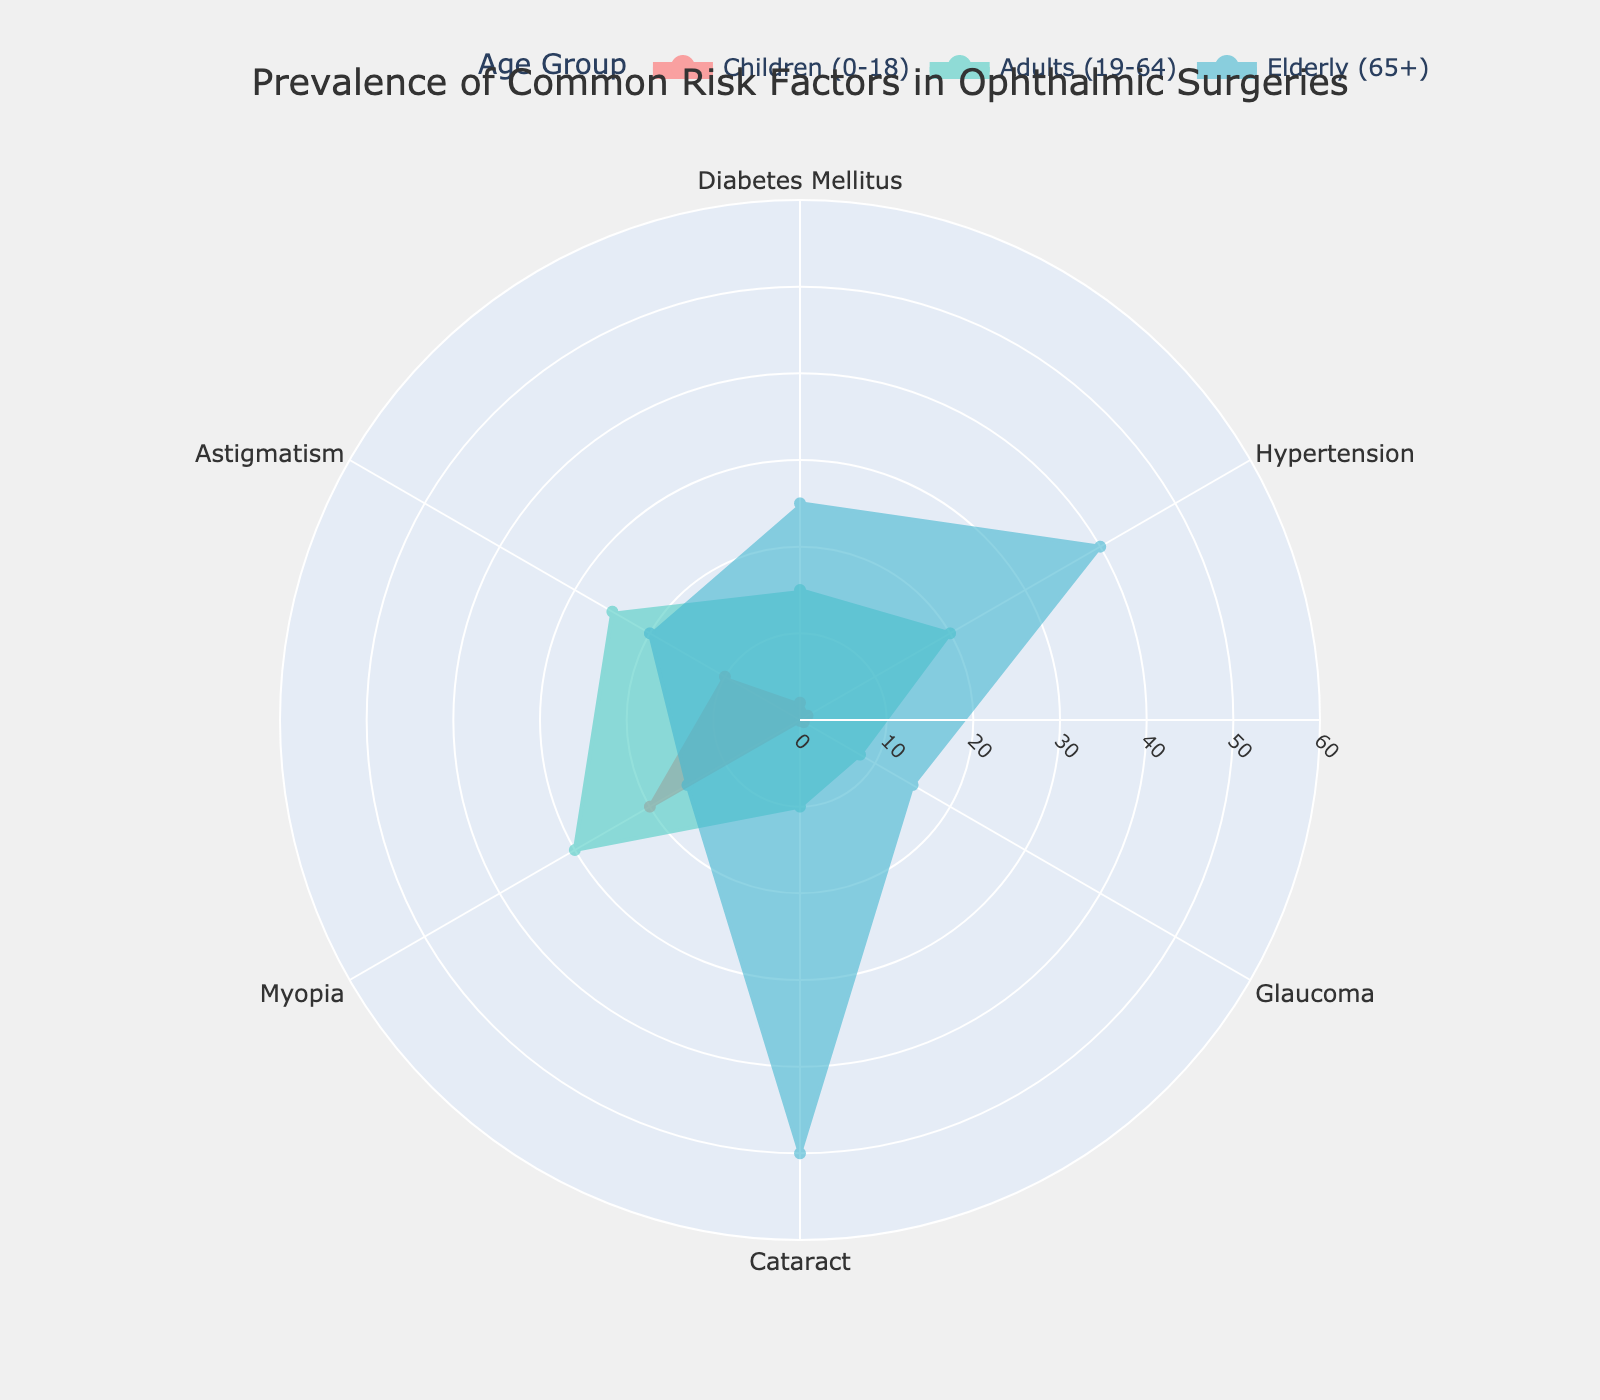What is the title of the figure? The title is usually located at the top of the figure and is straightforward to read. In this case, it states, "Prevalence of Common Risk Factors in Ophthalmic Surgeries."
Answer: Prevalence of Common Risk Factors in Ophthalmic Surgeries Which age group has the highest percentage of Hypertension? By inspecting the filled areas and reading the data labels around the polar chart, we can see that the age group "Elderly (65+)" has the largest radial distance in the Hypertension sector.
Answer: Elderly (65+) What is the difference in the prevalence of Myopia between Children and Adults? By reading the percentages from the labels or from the radial distances in the Myopia sector, we see Children (0-18) have 20% and Adults (19-64) have 30%. The difference is calculated as 30% - 20%.
Answer: 10% Which risk factor shows the largest increase in percentage from Children to Elderly? To determine this, we examine each risk factor's percentage for Children and Elderly. The risk factor with the largest difference (subtraction) indicates the largest increase. Cataract has the largest increase from 0.1% in Children to 50% in Elderly.
Answer: Cataract What is the average prevalence of Astigmatism across all age groups? Add the percentages for Astigmatism across all age groups (Children: 10%, Adults: 25%, Elderly: 20%) and divide by the number of age groups (3): (10 + 25 + 20)/3.
Answer: 18.33% Which two risk factors have similar prevalence in the Adult age group? By comparing the percentage values for each risk factor within the Adults group (Diabetes Mellitus: 15%, Hypertension: 20%, Glaucoma: 8%, Cataract: 10%, Myopia: 30%, Astigmatism: 25%), we notice that Hypertension and Astigmatism are relatively close (20% and 25%).
Answer: Hypertension, Astigmatism Which age group shows the highest prevalence of Cataract? Examine the radial distances in the Cataract sector for each age group. The Elderly (65+) group has the largest radial distance, indicating the highest prevalence (50%).
Answer: Elderly (65+) If we combine the prevalence of Diabetes Mellitus and Glaucoma in Children, what is the total percentage? By summing the percentages for Diabetes Mellitus (2%) and Glaucoma (0.5%) in the Children age group: 2% + 0.5%.
Answer: 2.5% Which risk factor has the smallest prevalence across all age groups? Identify the smallest values in the polar chart for each risk factor. Cataract in Children (0.1%) is the smallest overall value.
Answer: Cataract (Children) 